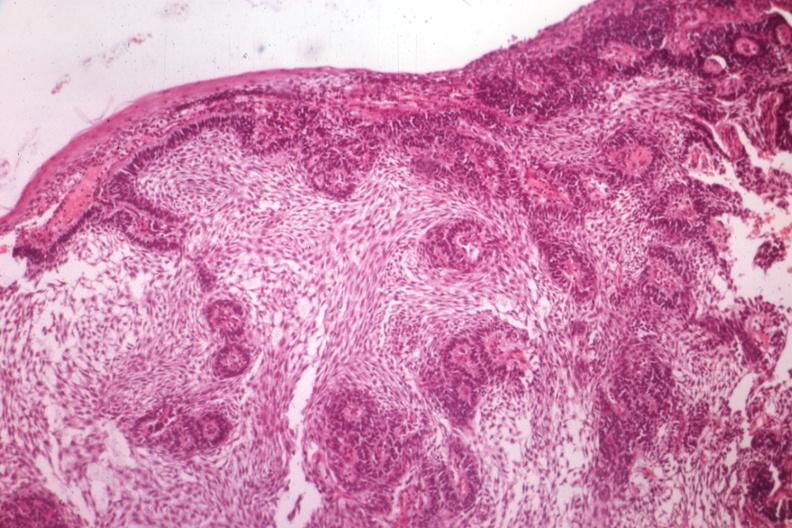s ameloblastoma present?
Answer the question using a single word or phrase. Yes 